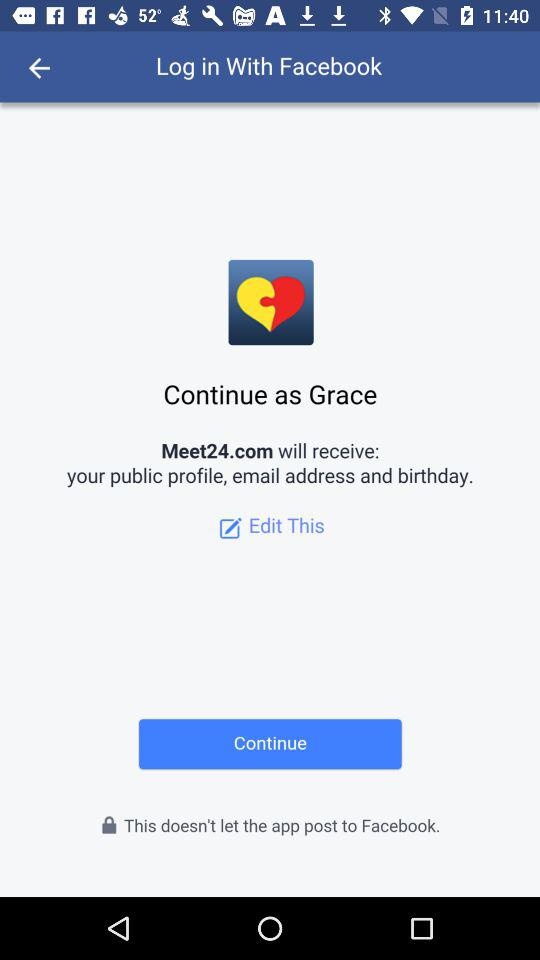What application is asking for permission? The application that is asking for permission is "Meet24.com". 